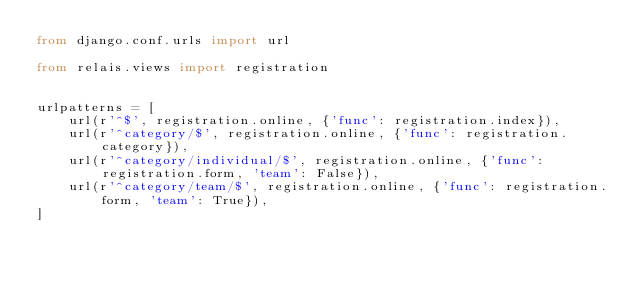Convert code to text. <code><loc_0><loc_0><loc_500><loc_500><_Python_>from django.conf.urls import url

from relais.views import registration


urlpatterns = [
    url(r'^$', registration.online, {'func': registration.index}),
    url(r'^category/$', registration.online, {'func': registration.category}),
    url(r'^category/individual/$', registration.online, {'func': registration.form, 'team': False}),
    url(r'^category/team/$', registration.online, {'func': registration.form, 'team': True}),
]
</code> 